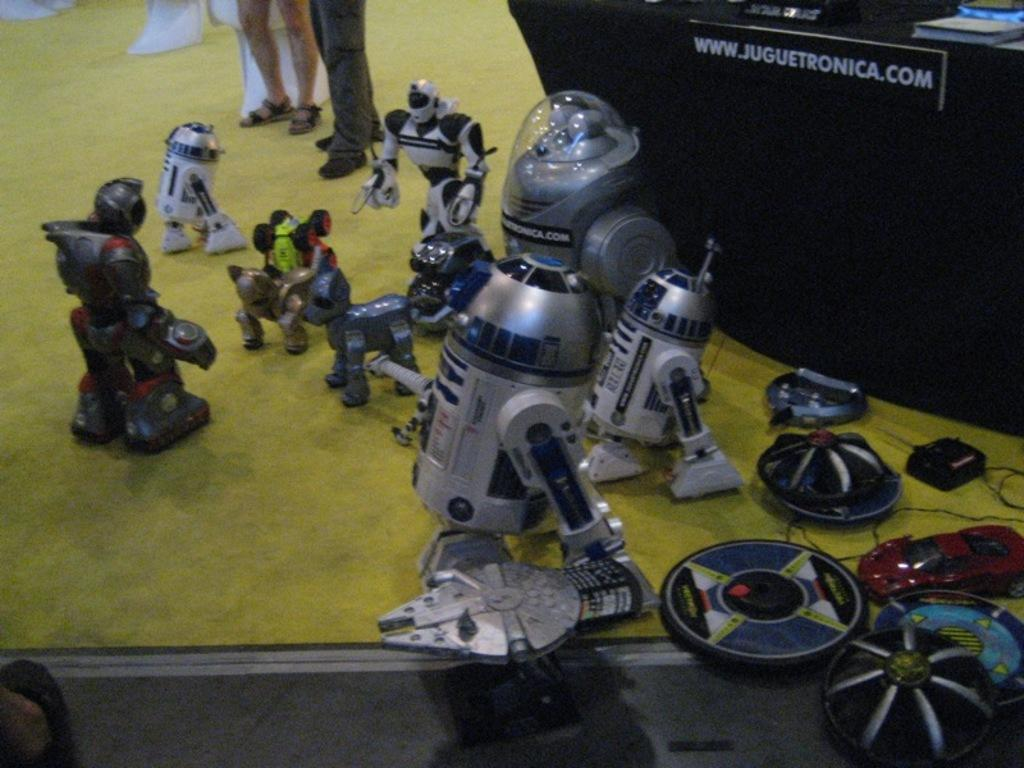What objects are present in the image? There are toys in the image. What is located behind the toys? There is a table behind the toys. What items can be seen on the table? There are books on the table. Whose legs might be visible at the top of the image? Some legs are visible at the top of the image, possibly belonging to a person. Can you see a note being passed between the toys in the image? There is no note visible in the image, nor is there any indication of interaction between the toys. 